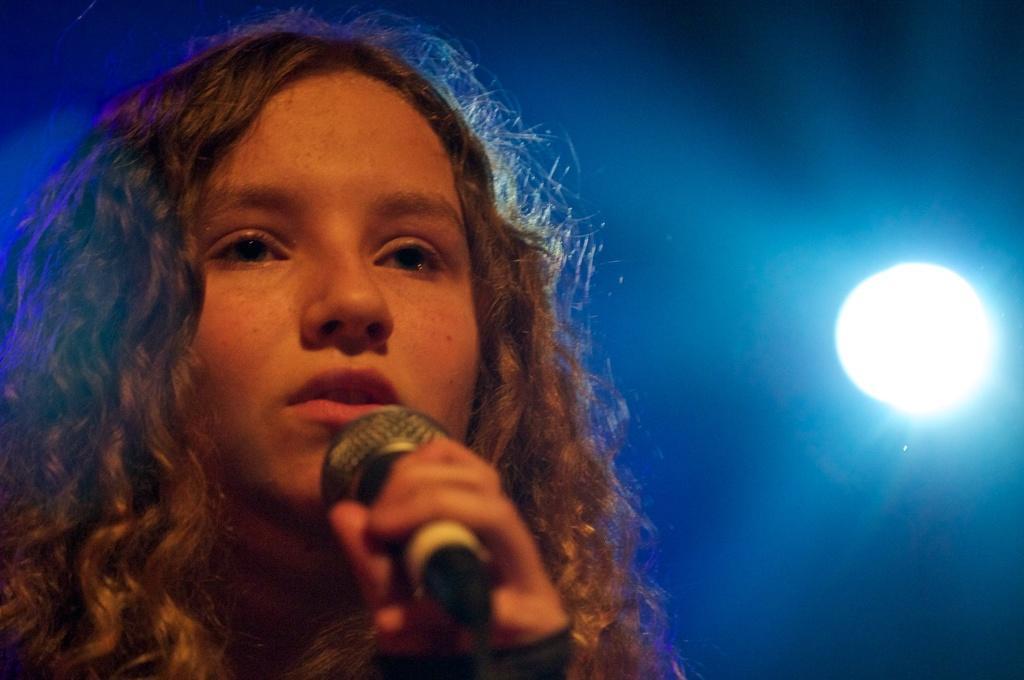Could you give a brief overview of what you see in this image? In the left, a girl is standing and holding a mike. The background is blue in color. In the middle right, focus light is visible. This image is taken on the stage during night time. 